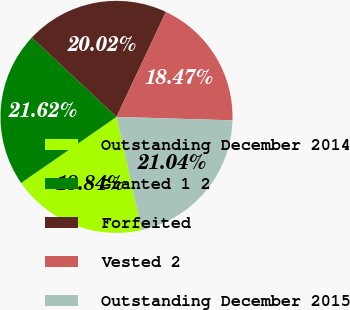Convert chart. <chart><loc_0><loc_0><loc_500><loc_500><pie_chart><fcel>Outstanding December 2014<fcel>Granted 1 2<fcel>Forfeited<fcel>Vested 2<fcel>Outstanding December 2015<nl><fcel>18.84%<fcel>21.62%<fcel>20.02%<fcel>18.47%<fcel>21.04%<nl></chart> 